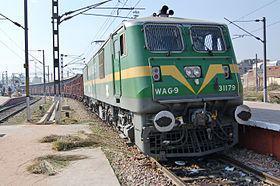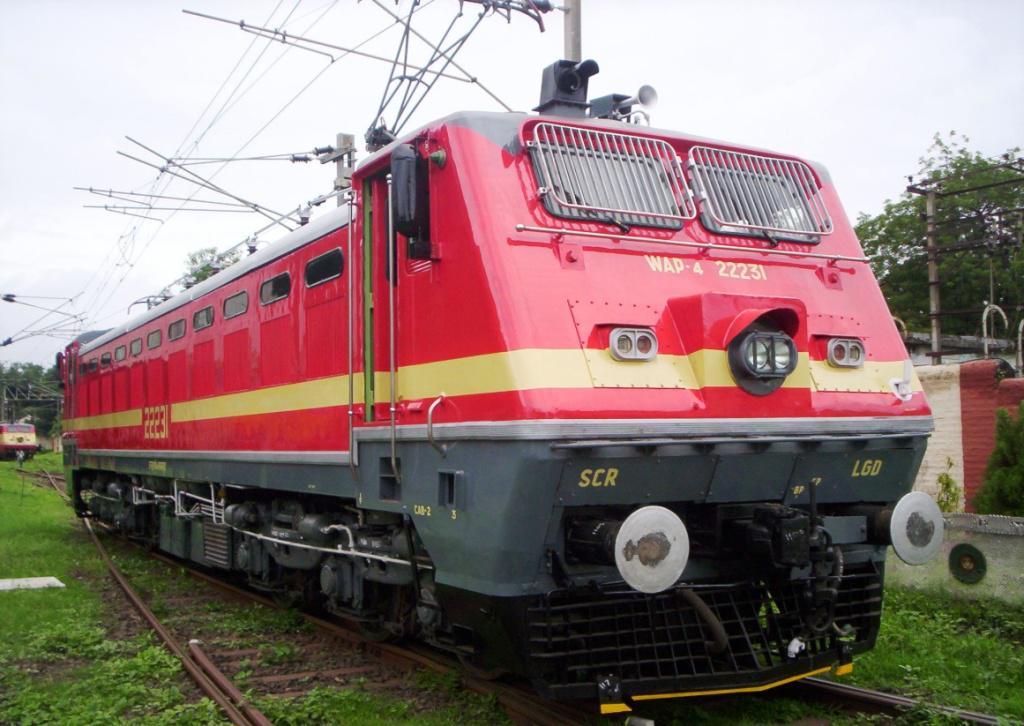The first image is the image on the left, the second image is the image on the right. Examine the images to the left and right. Is the description "The train in the image on the left is moving towards the left." accurate? Answer yes or no. No. The first image is the image on the left, the second image is the image on the right. Considering the images on both sides, is "The images include exactly one train with a yellow-striped green front car, and it is headed rightward." valid? Answer yes or no. Yes. 